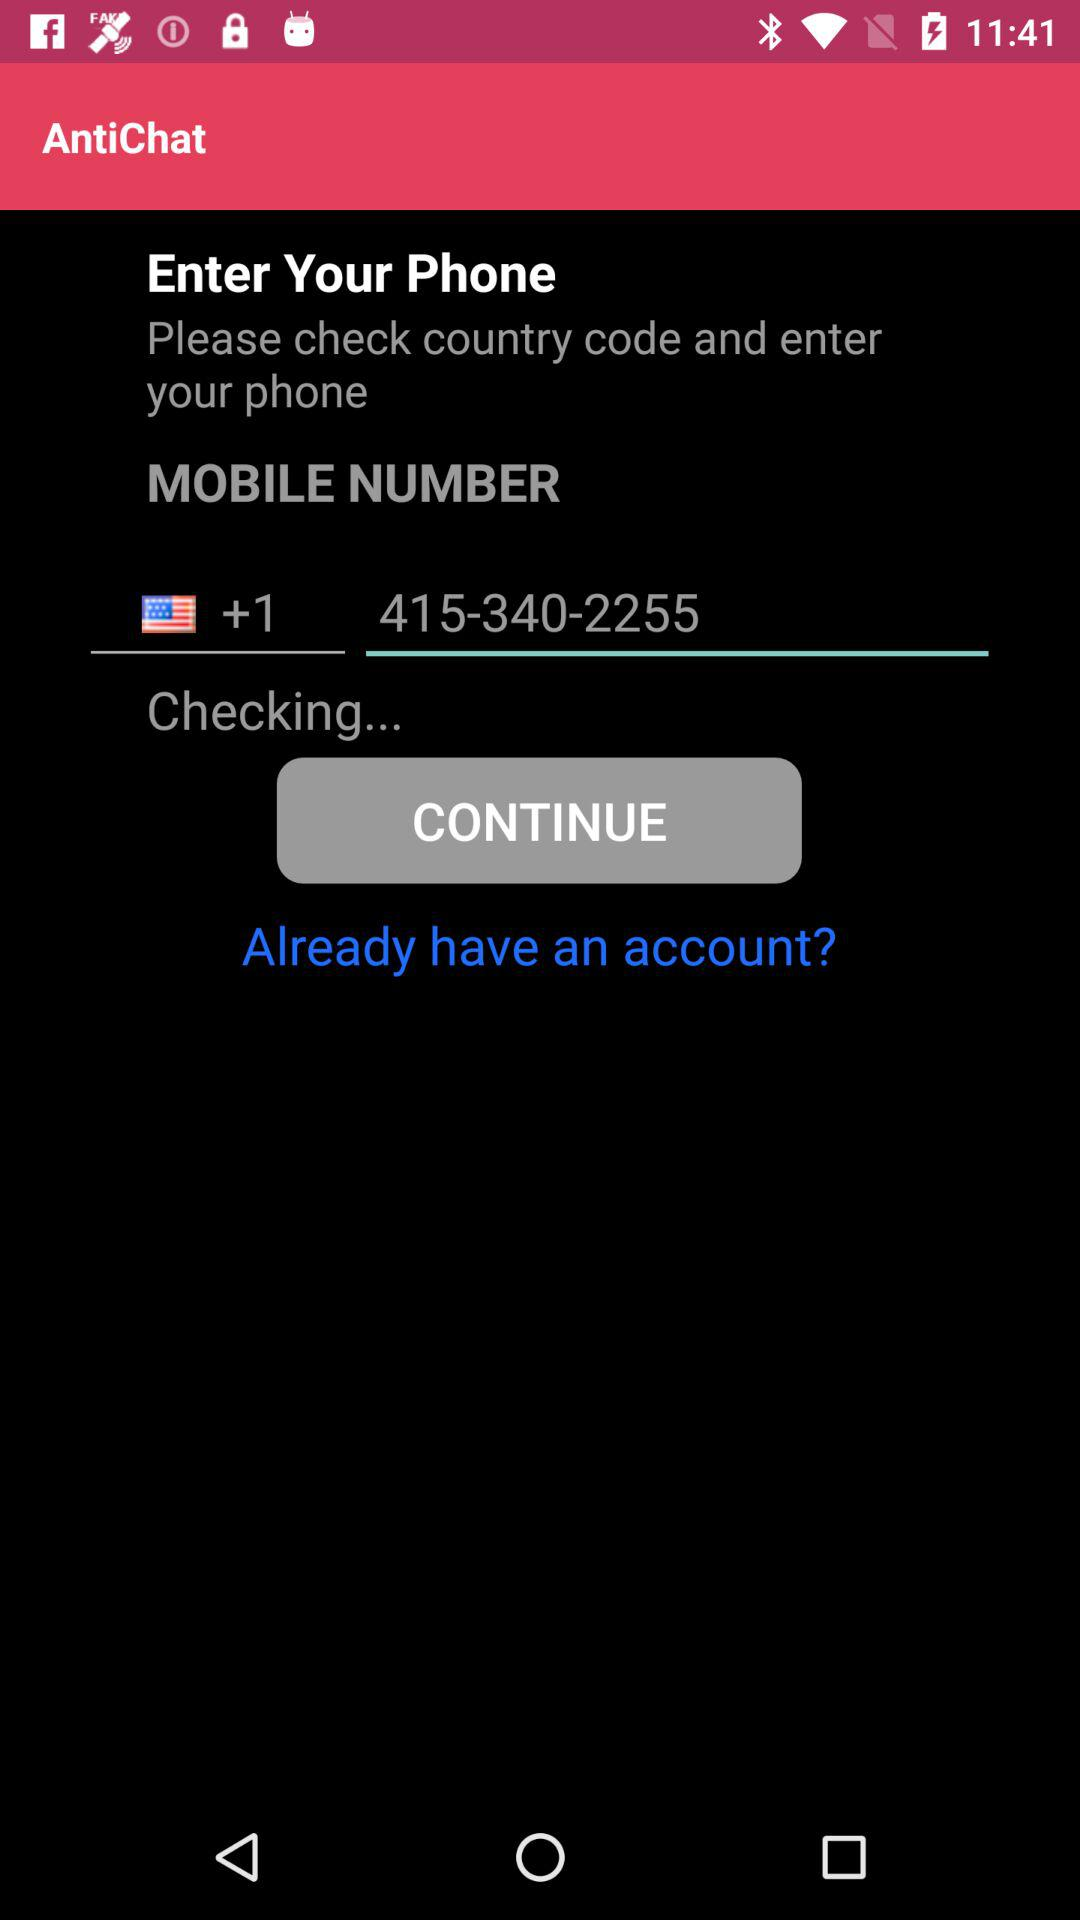What is the country code given? The given country code is "+1". 